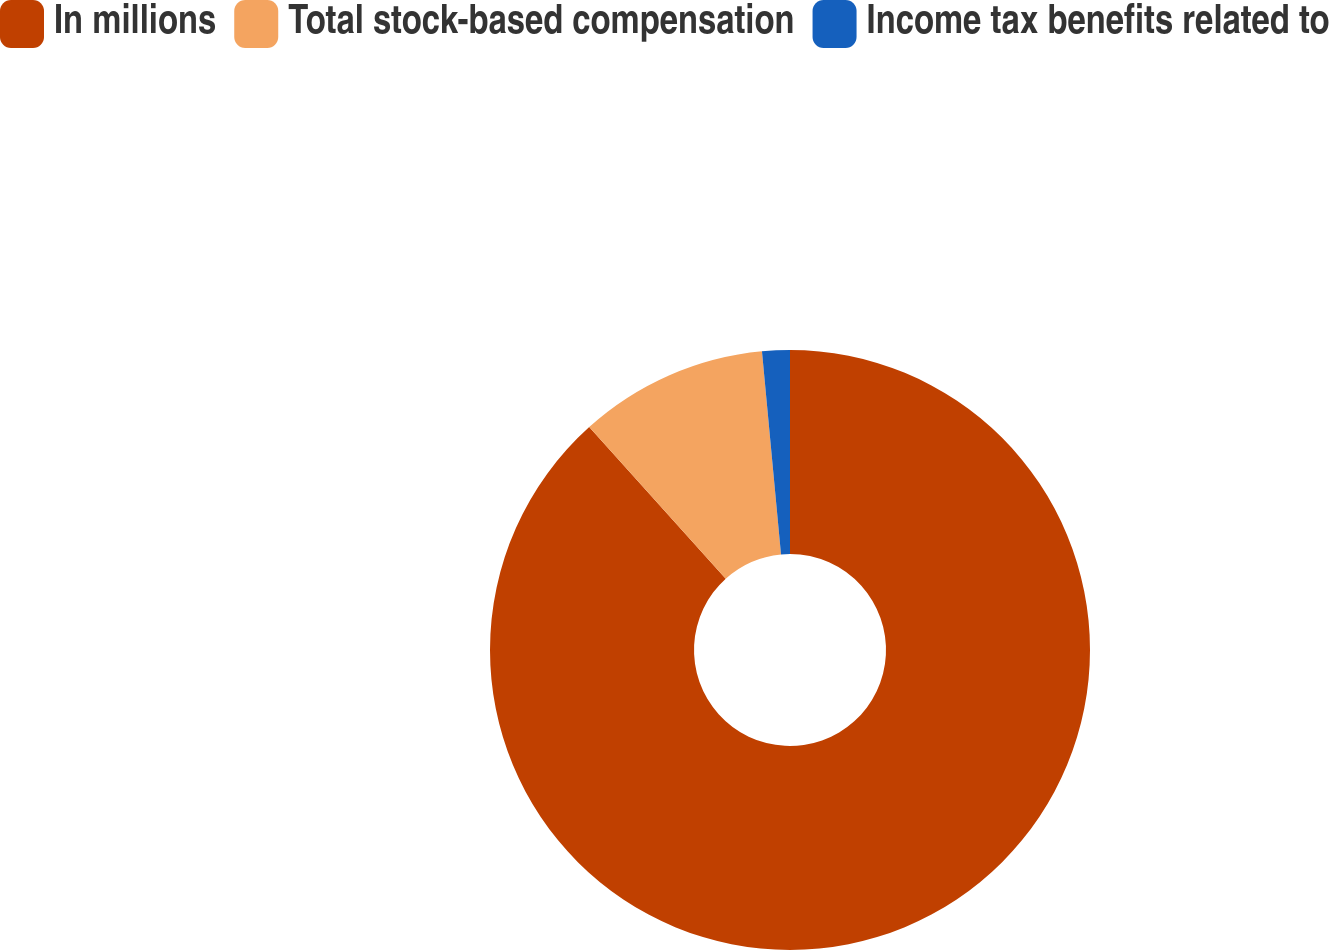<chart> <loc_0><loc_0><loc_500><loc_500><pie_chart><fcel>In millions<fcel>Total stock-based compensation<fcel>Income tax benefits related to<nl><fcel>88.33%<fcel>10.18%<fcel>1.49%<nl></chart> 